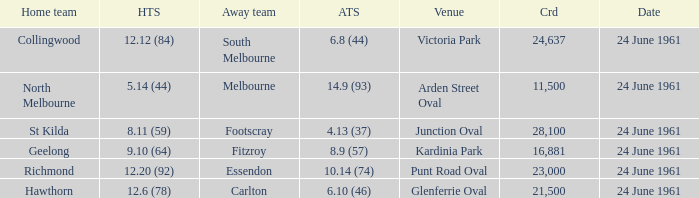Who was the home team that scored 12.6 (78)? Hawthorn. 